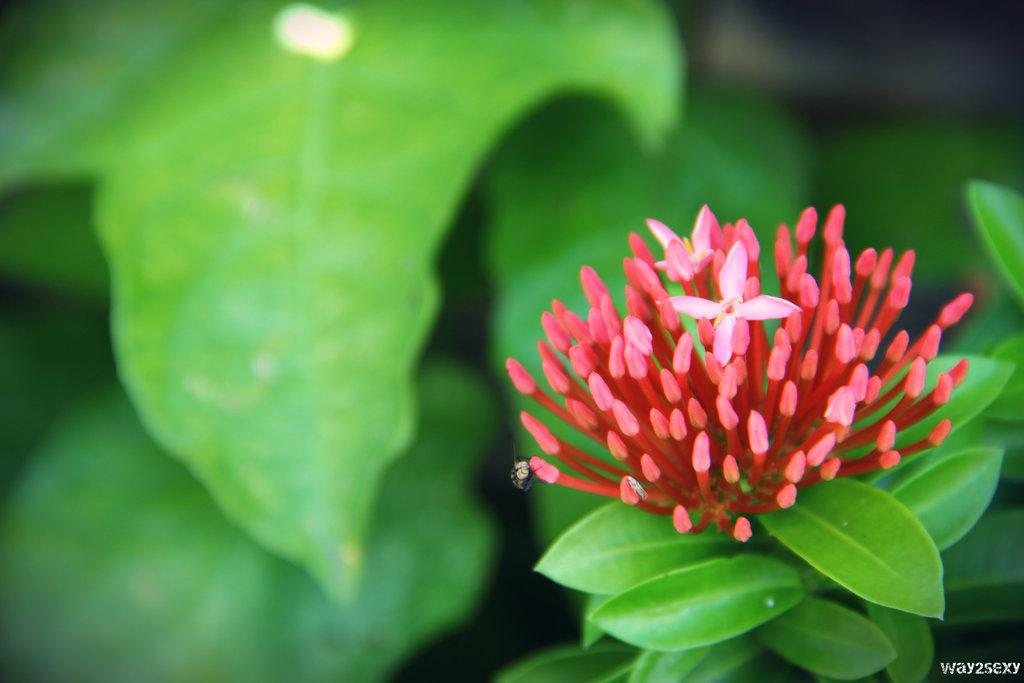What type of plant life is present in the image? There is a flower grown on a plant in the image. What other living organism can be seen in the image? There is an insect in the image. What color are the leaves in the image? The leaves in the image are green. What action is the dad performing in the image? There is no dad present in the image, so it is not possible to answer that question. 